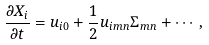Convert formula to latex. <formula><loc_0><loc_0><loc_500><loc_500>\frac { \partial X _ { i } } { \partial t } = u _ { i 0 } + \frac { 1 } { 2 } u _ { i m n } \Sigma _ { m n } + \cdots ,</formula> 